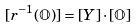Convert formula to latex. <formula><loc_0><loc_0><loc_500><loc_500>[ r ^ { - 1 } ( \mathbb { O } ) ] = [ Y ] \cdot [ \mathbb { O } ]</formula> 